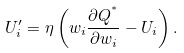Convert formula to latex. <formula><loc_0><loc_0><loc_500><loc_500>U _ { i } ^ { \prime } = \eta \left ( w _ { i } \frac { \partial Q ^ { ^ { * } } } { \partial w _ { i } } - U _ { i } \right ) .</formula> 